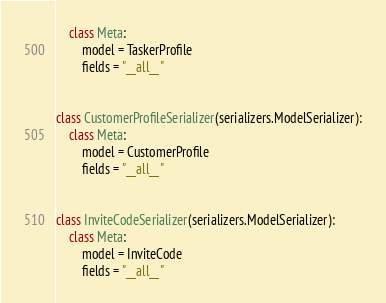Convert code to text. <code><loc_0><loc_0><loc_500><loc_500><_Python_>    class Meta:
        model = TaskerProfile
        fields = "__all__"


class CustomerProfileSerializer(serializers.ModelSerializer):
    class Meta:
        model = CustomerProfile
        fields = "__all__"


class InviteCodeSerializer(serializers.ModelSerializer):
    class Meta:
        model = InviteCode
        fields = "__all__"
</code> 